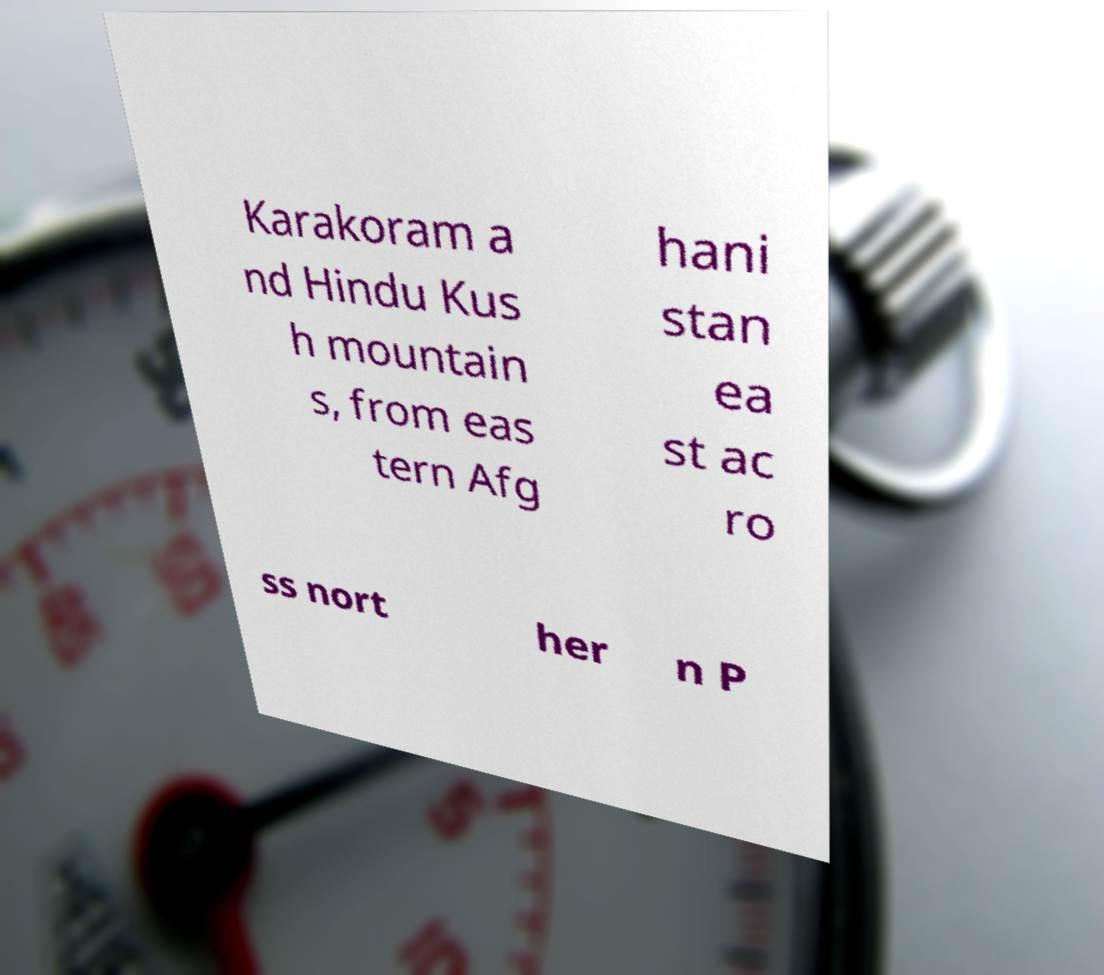For documentation purposes, I need the text within this image transcribed. Could you provide that? Karakoram a nd Hindu Kus h mountain s, from eas tern Afg hani stan ea st ac ro ss nort her n P 